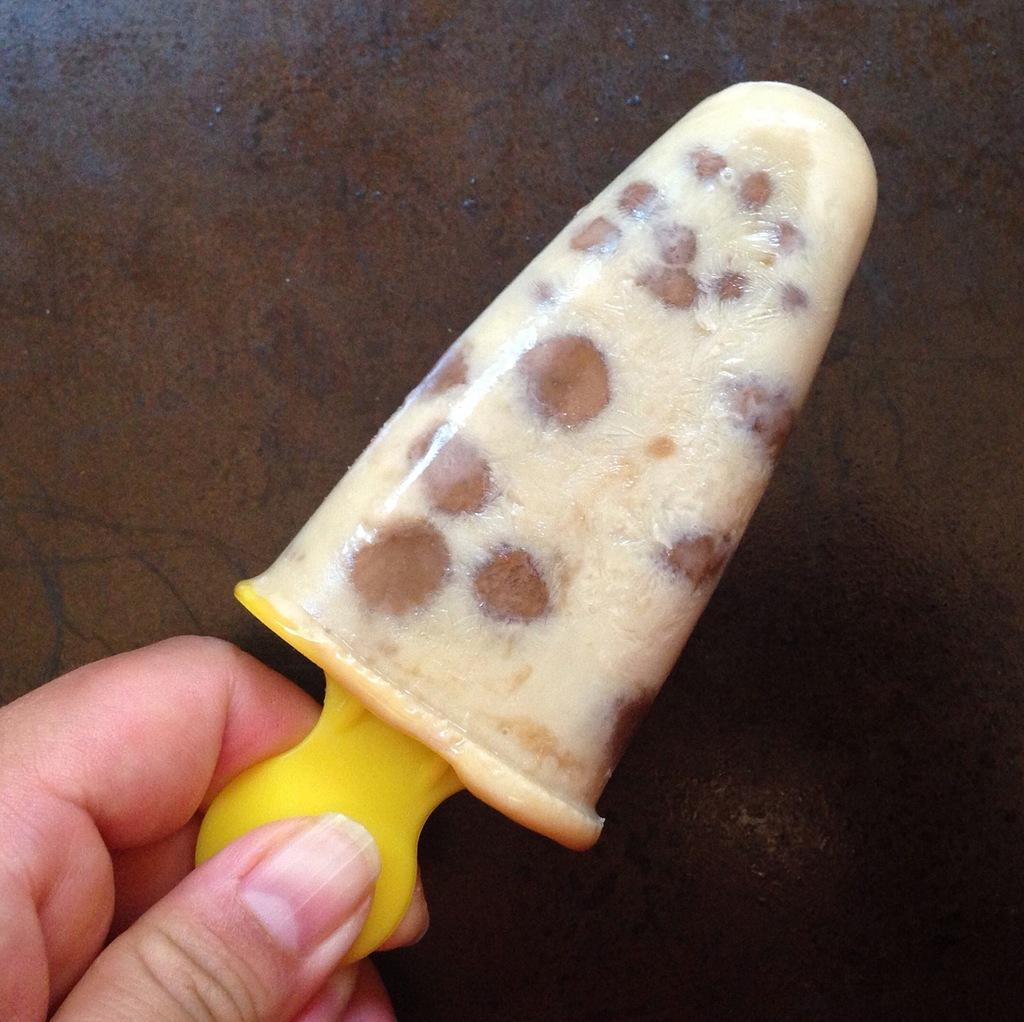In one or two sentences, can you explain what this image depicts? In this image there is a hand holding a ice-cream. 